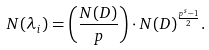Convert formula to latex. <formula><loc_0><loc_0><loc_500><loc_500>N ( \lambda _ { i } ) = \left ( \frac { N ( D ) } { p } \right ) \cdot N ( D ) ^ { \frac { p ^ { s } - 1 } { 2 } } .</formula> 